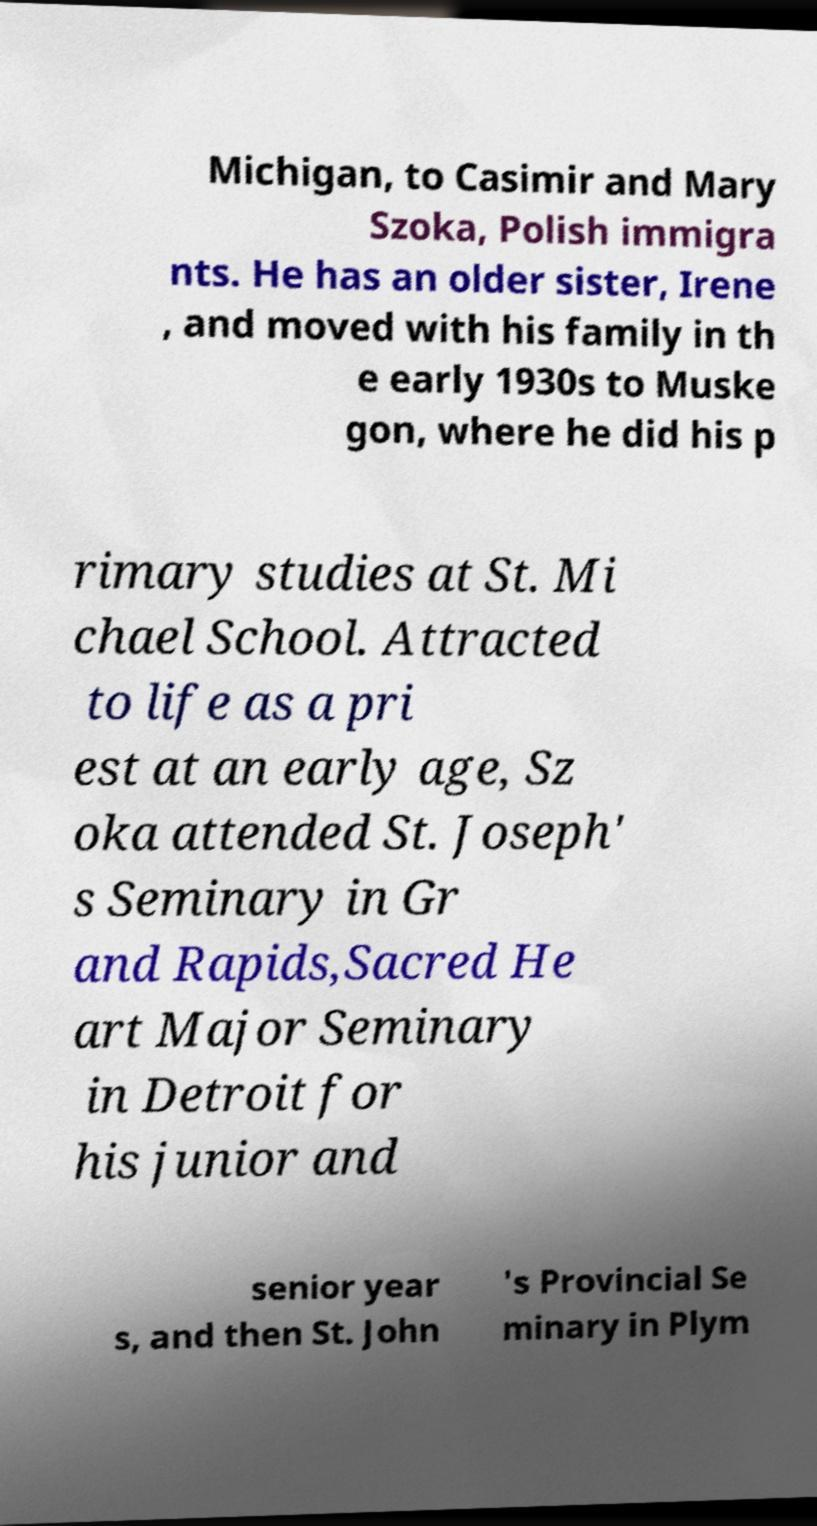Could you assist in decoding the text presented in this image and type it out clearly? Michigan, to Casimir and Mary Szoka, Polish immigra nts. He has an older sister, Irene , and moved with his family in th e early 1930s to Muske gon, where he did his p rimary studies at St. Mi chael School. Attracted to life as a pri est at an early age, Sz oka attended St. Joseph' s Seminary in Gr and Rapids,Sacred He art Major Seminary in Detroit for his junior and senior year s, and then St. John 's Provincial Se minary in Plym 